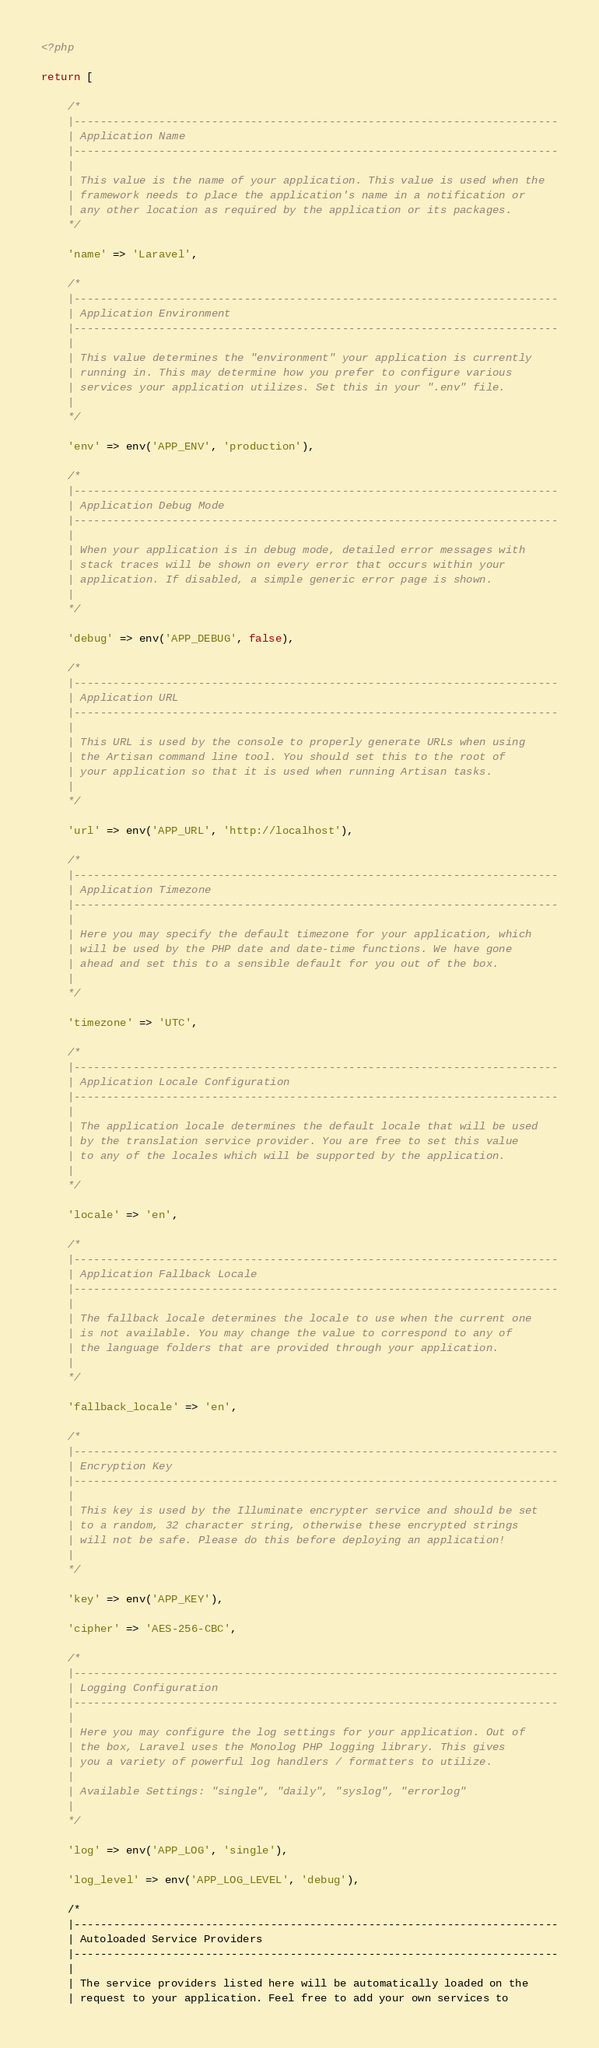Convert code to text. <code><loc_0><loc_0><loc_500><loc_500><_PHP_><?php

return [

    /*
    |--------------------------------------------------------------------------
    | Application Name
    |--------------------------------------------------------------------------
    |
    | This value is the name of your application. This value is used when the
    | framework needs to place the application's name in a notification or
    | any other location as required by the application or its packages.
    */

    'name' => 'Laravel',

    /*
    |--------------------------------------------------------------------------
    | Application Environment
    |--------------------------------------------------------------------------
    |
    | This value determines the "environment" your application is currently
    | running in. This may determine how you prefer to configure various
    | services your application utilizes. Set this in your ".env" file.
    |
    */

    'env' => env('APP_ENV', 'production'),

    /*
    |--------------------------------------------------------------------------
    | Application Debug Mode
    |--------------------------------------------------------------------------
    |
    | When your application is in debug mode, detailed error messages with
    | stack traces will be shown on every error that occurs within your
    | application. If disabled, a simple generic error page is shown.
    |
    */

    'debug' => env('APP_DEBUG', false),

    /*
    |--------------------------------------------------------------------------
    | Application URL
    |--------------------------------------------------------------------------
    |
    | This URL is used by the console to properly generate URLs when using
    | the Artisan command line tool. You should set this to the root of
    | your application so that it is used when running Artisan tasks.
    |
    */

    'url' => env('APP_URL', 'http://localhost'),

    /*
    |--------------------------------------------------------------------------
    | Application Timezone
    |--------------------------------------------------------------------------
    |
    | Here you may specify the default timezone for your application, which
    | will be used by the PHP date and date-time functions. We have gone
    | ahead and set this to a sensible default for you out of the box.
    |
    */

    'timezone' => 'UTC',

    /*
    |--------------------------------------------------------------------------
    | Application Locale Configuration
    |--------------------------------------------------------------------------
    |
    | The application locale determines the default locale that will be used
    | by the translation service provider. You are free to set this value
    | to any of the locales which will be supported by the application.
    |
    */

    'locale' => 'en',

    /*
    |--------------------------------------------------------------------------
    | Application Fallback Locale
    |--------------------------------------------------------------------------
    |
    | The fallback locale determines the locale to use when the current one
    | is not available. You may change the value to correspond to any of
    | the language folders that are provided through your application.
    |
    */

    'fallback_locale' => 'en',

    /*
    |--------------------------------------------------------------------------
    | Encryption Key
    |--------------------------------------------------------------------------
    |
    | This key is used by the Illuminate encrypter service and should be set
    | to a random, 32 character string, otherwise these encrypted strings
    | will not be safe. Please do this before deploying an application!
    |
    */

    'key' => env('APP_KEY'),

    'cipher' => 'AES-256-CBC',

    /*
    |--------------------------------------------------------------------------
    | Logging Configuration
    |--------------------------------------------------------------------------
    |
    | Here you may configure the log settings for your application. Out of
    | the box, Laravel uses the Monolog PHP logging library. This gives
    | you a variety of powerful log handlers / formatters to utilize.
    |
    | Available Settings: "single", "daily", "syslog", "errorlog"
    |
    */

    'log' => env('APP_LOG', 'single'),

    'log_level' => env('APP_LOG_LEVEL', 'debug'),

    /*
    |--------------------------------------------------------------------------
    | Autoloaded Service Providers
    |--------------------------------------------------------------------------
    |
    | The service providers listed here will be automatically loaded on the
    | request to your application. Feel free to add your own services to</code> 